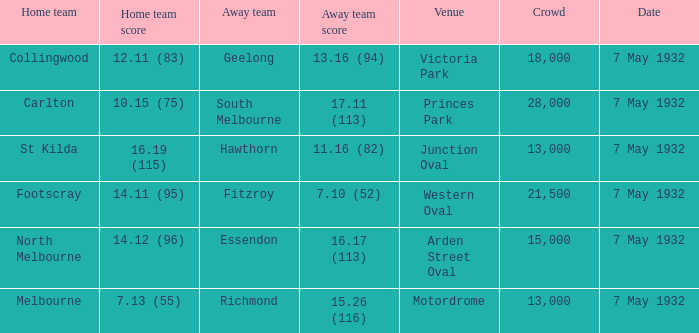Which home team has a Away team of hawthorn? St Kilda. 